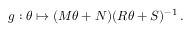Convert formula to latex. <formula><loc_0><loc_0><loc_500><loc_500>g \colon \theta \mapsto ( M \theta + N ) ( R \theta + S ) ^ { - 1 } \, .</formula> 